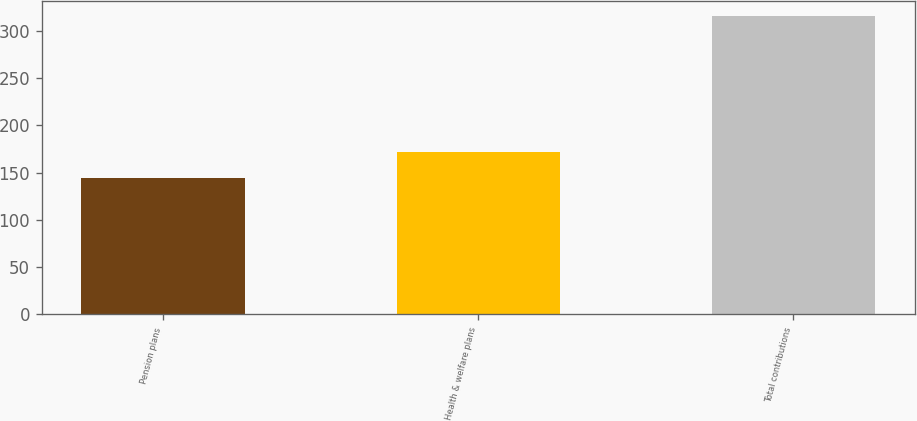Convert chart to OTSL. <chart><loc_0><loc_0><loc_500><loc_500><bar_chart><fcel>Pension plans<fcel>Health & welfare plans<fcel>Total contributions<nl><fcel>144<fcel>172<fcel>316<nl></chart> 